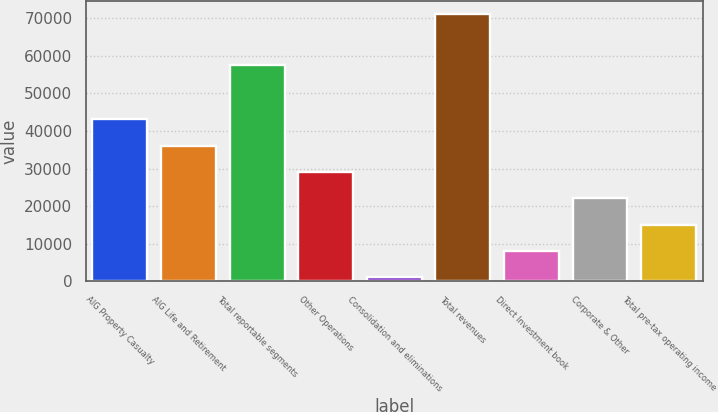<chart> <loc_0><loc_0><loc_500><loc_500><bar_chart><fcel>AIG Property Casualty<fcel>AIG Life and Retirement<fcel>Total reportable segments<fcel>Other Operations<fcel>Consolidation and eliminations<fcel>Total revenues<fcel>Direct Investment book<fcel>Corporate & Other<fcel>Total pre-tax operating income<nl><fcel>43069<fcel>36081<fcel>57599<fcel>29093<fcel>1141<fcel>71021<fcel>8129<fcel>22105<fcel>15117<nl></chart> 